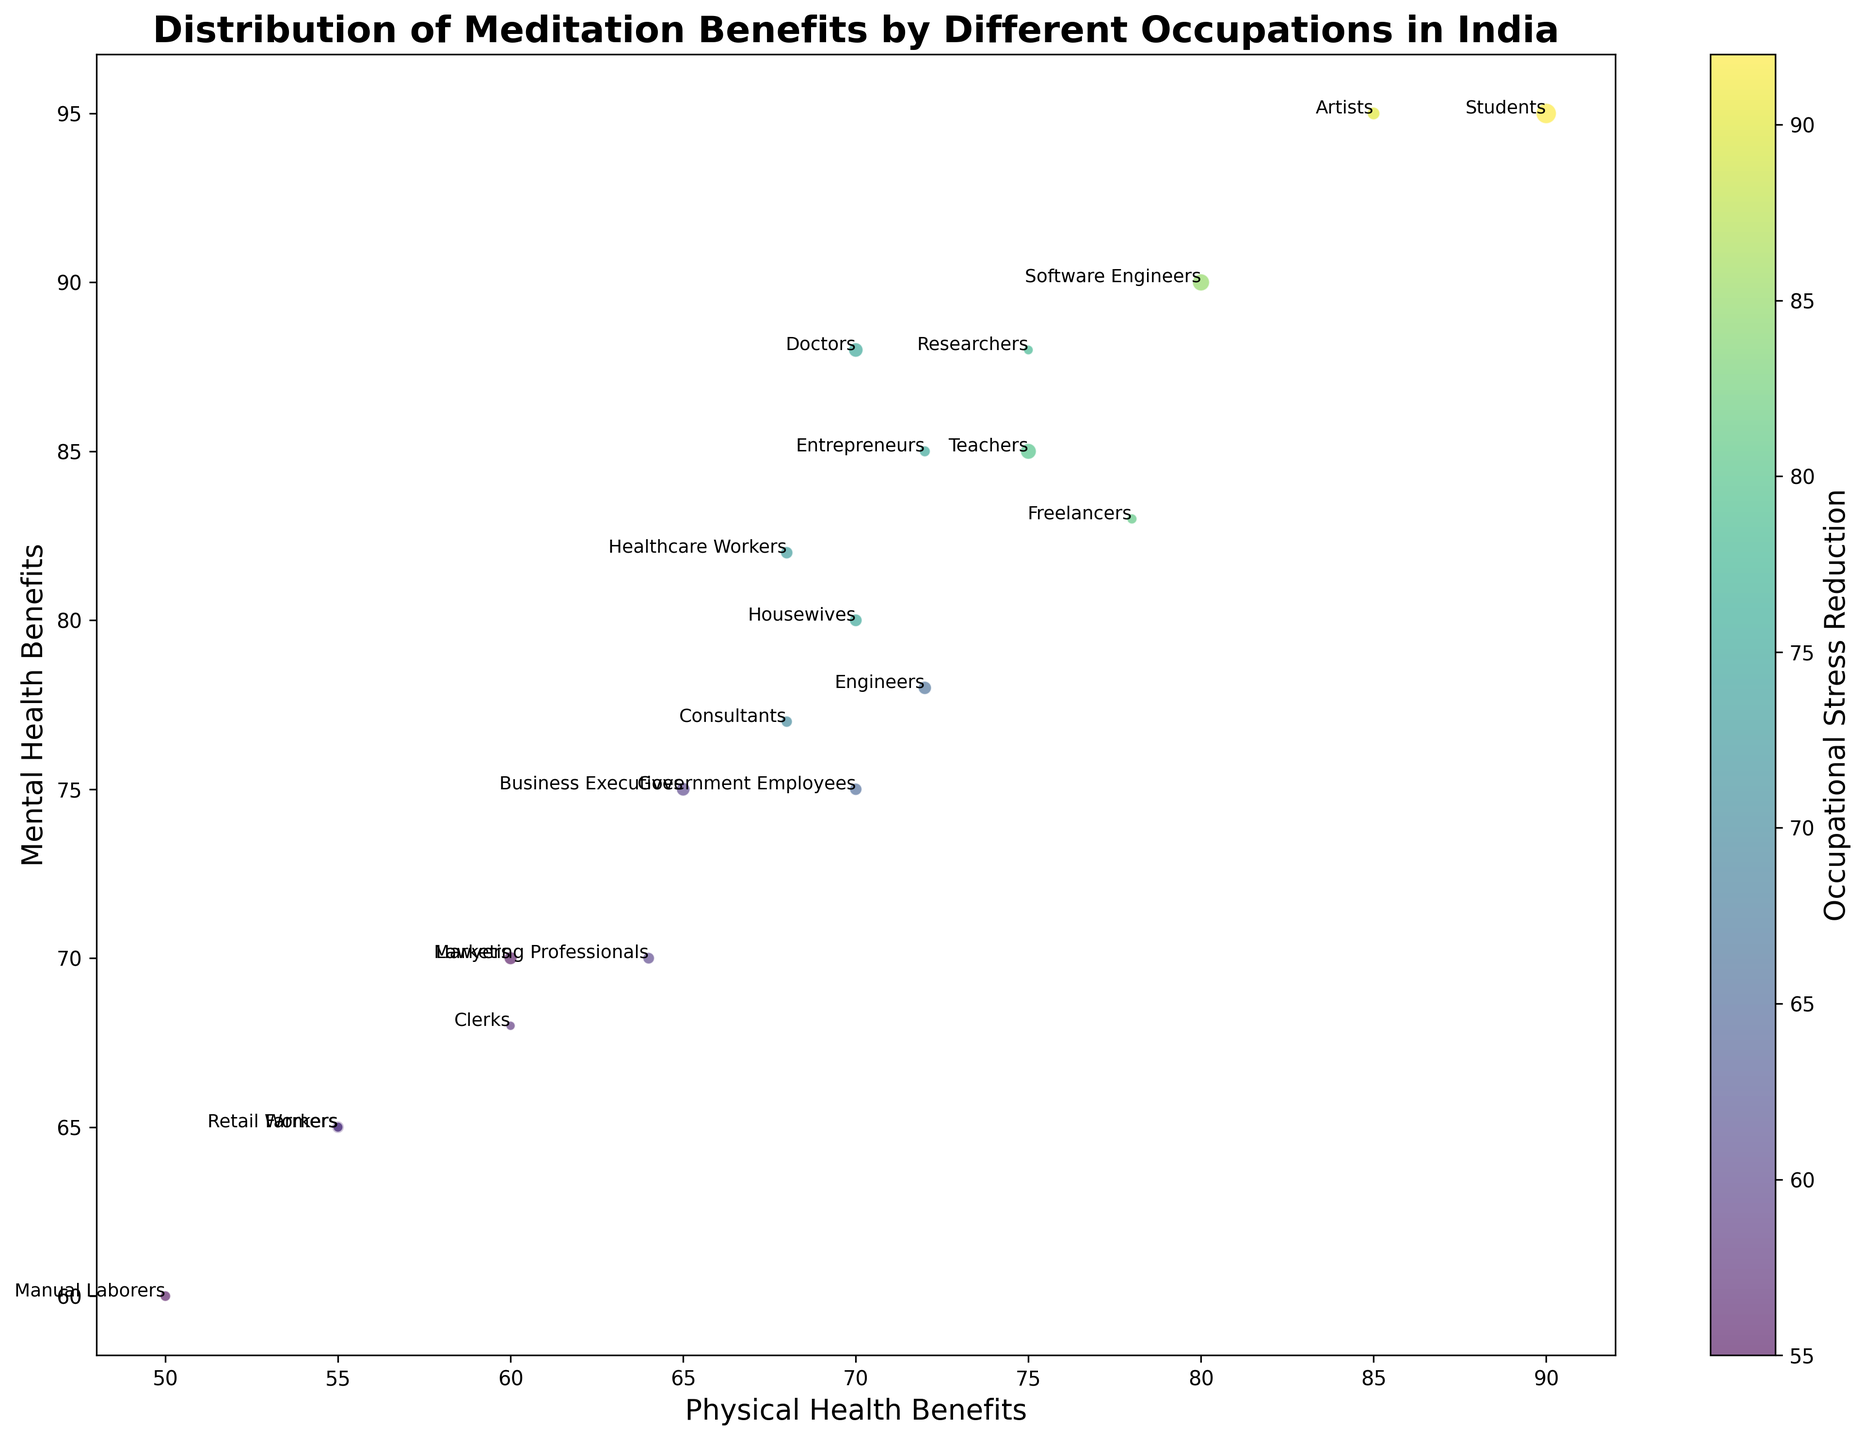what occupation experiences the highest mental health benefits? Based on the y-axis (Mental Health Benefits), the occupation with the highest value is "Students" with a value of 95.
Answer: Students Between Software Engineers and Freelancers, which occupation shows better stress reduction? Refer to the color bar indicating Occupational Stress Reduction. Software Engineers have a value of 85 (darker color), while Freelancers have a value of 81 (lighter color). Therefore, Software Engineers show better stress reduction.
Answer: Software Engineers What is the median value of physical health benefits for Teachers, Doctors, and Engineers? Arrange the values for Teachers (75), Doctors (70), and Engineers (72). The median value is the middle value when the data is ordered, so it is 72.
Answer: 72 Which occupation has the largest bubble size, and what does it signify? The largest bubble corresponds to the "Students" occupation. The size of the bubble indicates the number of practitioners, meaning "Students" have the highest number of practitioners, which is 500.
Answer: Students Compare the physical health benefits of Housewives and Farmers and determine the difference. Housewives have a physical health benefit value of 70, while Farmers have a value of 55. The difference is 70 - 55 = 15.
Answer: 15 Which occupation has a better balance between physical and mental health benefits (i.e., closer values) — Lawyers or Business Executives? Lawyers have values of 60 (physical) and 70 (mental), with a difference of 10. Business Executives have values of 65 (physical) and 75 (mental), with a difference of 10. Both occupations have the same difference, indicating equal balance.
Answer: Both Are there any occupations with balanced values in all three categories (physical, mental, stress reduction)? Checking values for a balance across all categories (similar or equal values). None of the occupations have exactly the same values across all three categories.
Answer: No Which occupation has the least physical health benefits and how does its number of practitioners compare to Housewives? Manual Laborers have the least physical health benefits at 50. Comparing practitioners, Manual Laborers have 130 practitioners, and Housewives have 190 practitioners, meaning Housewives have more practitioners.
Answer: Manual Laborers, Housewives have more 